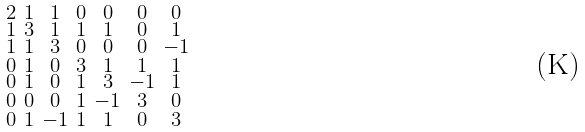Convert formula to latex. <formula><loc_0><loc_0><loc_500><loc_500>\begin{smallmatrix} 2 & 1 & 1 & 0 & 0 & 0 & 0 \\ 1 & 3 & 1 & 1 & 1 & 0 & 1 \\ 1 & 1 & 3 & 0 & 0 & 0 & - 1 \\ 0 & 1 & 0 & 3 & 1 & 1 & 1 \\ 0 & 1 & 0 & 1 & 3 & - 1 & 1 \\ 0 & 0 & 0 & 1 & - 1 & 3 & 0 \\ 0 & 1 & - 1 & 1 & 1 & 0 & 3 \end{smallmatrix}</formula> 